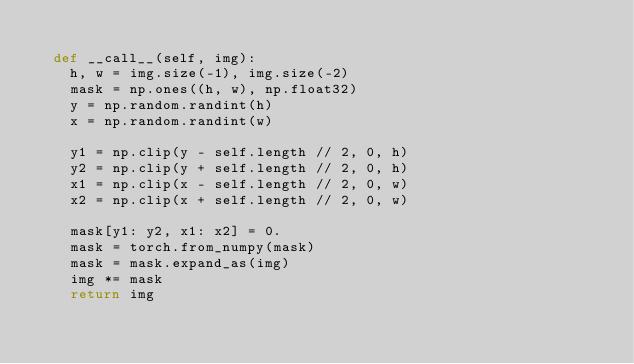<code> <loc_0><loc_0><loc_500><loc_500><_Python_>
  def __call__(self, img):
    h, w = img.size(-1), img.size(-2)
    mask = np.ones((h, w), np.float32)
    y = np.random.randint(h)
    x = np.random.randint(w)

    y1 = np.clip(y - self.length // 2, 0, h)
    y2 = np.clip(y + self.length // 2, 0, h)
    x1 = np.clip(x - self.length // 2, 0, w)
    x2 = np.clip(x + self.length // 2, 0, w)

    mask[y1: y2, x1: x2] = 0.
    mask = torch.from_numpy(mask)
    mask = mask.expand_as(img)
    img *= mask
    return img
</code> 